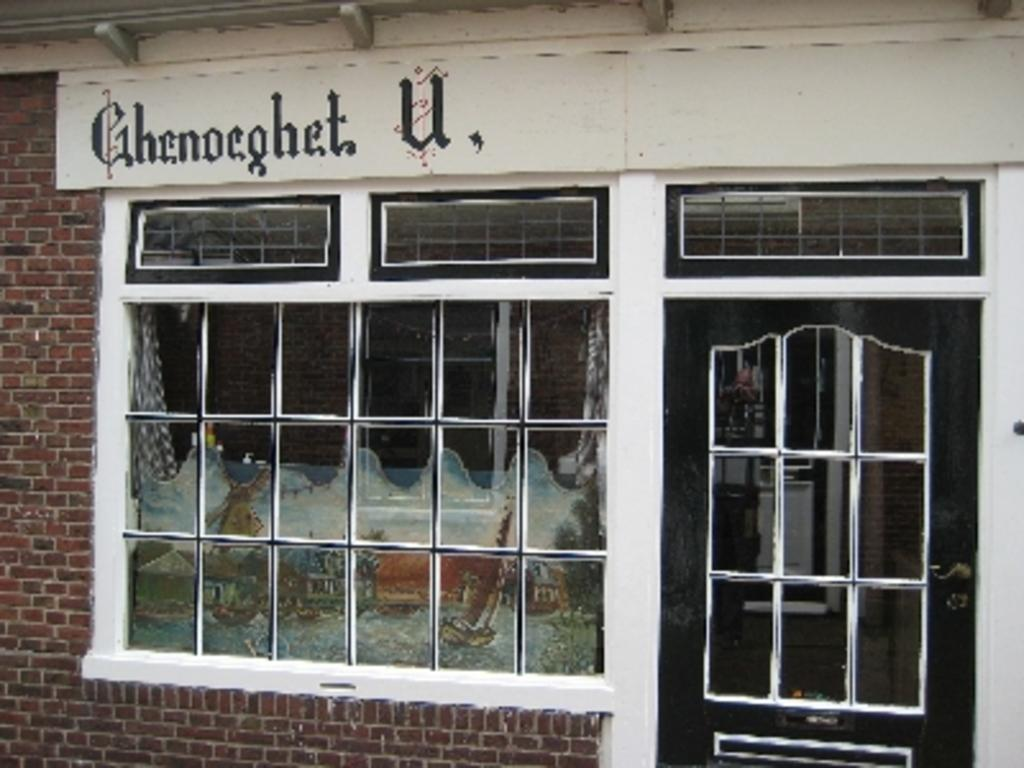Provide a one-sentence caption for the provided image. A storefront with the name Ghenoeghet U on it. 